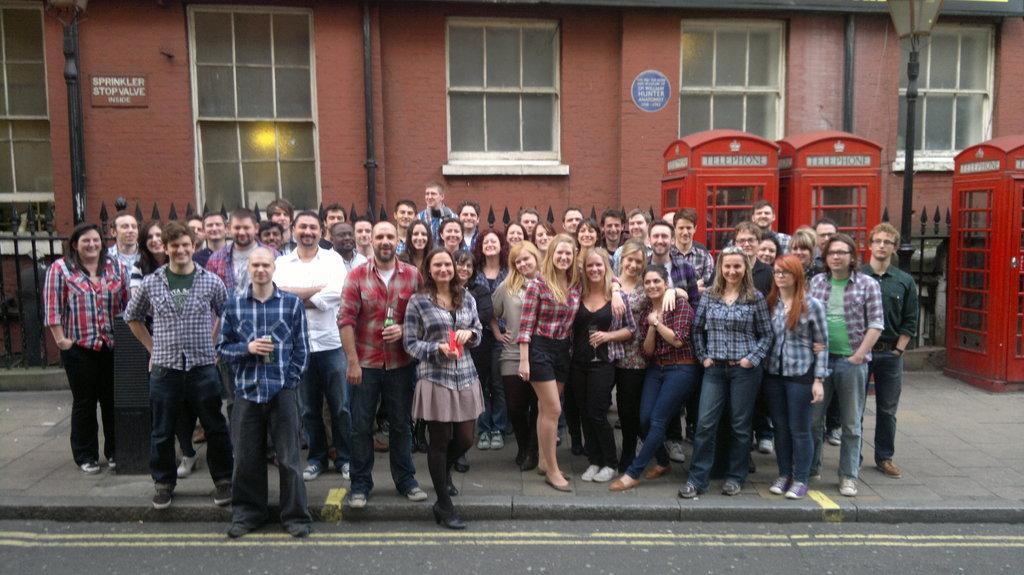In one or two sentences, can you explain what this image depicts? In the picture there is a road, beside the road there is a footpath present, on the footpath there are many people standing, behind them there is an iron fence, there are telephone booths present, there is a wall of a building, on the wall there are many glass windows present, beside the people there is a pole with the light. 